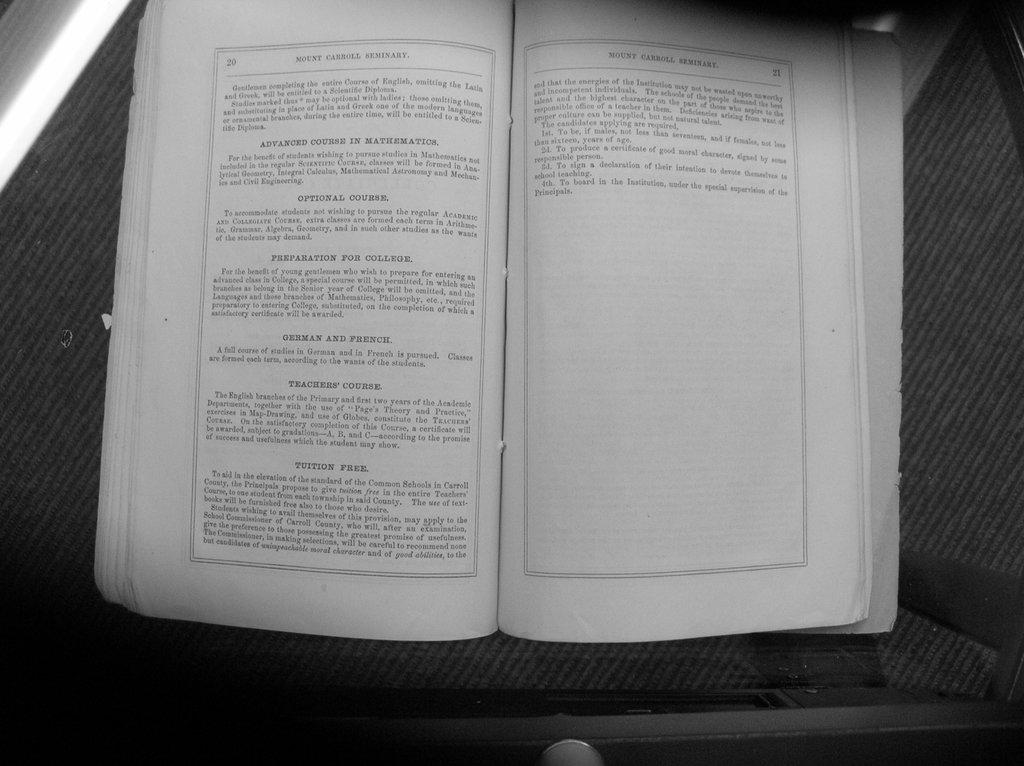Provide a one-sentence caption for the provided image. A book about Mount Carroll that's on page 20. 